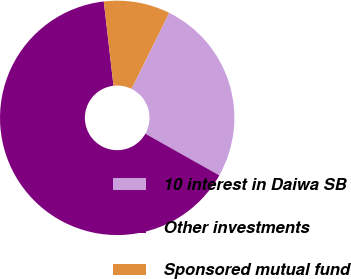<chart> <loc_0><loc_0><loc_500><loc_500><pie_chart><fcel>10 interest in Daiwa SB<fcel>Other investments<fcel>Sponsored mutual fund<nl><fcel>25.86%<fcel>65.02%<fcel>9.13%<nl></chart> 